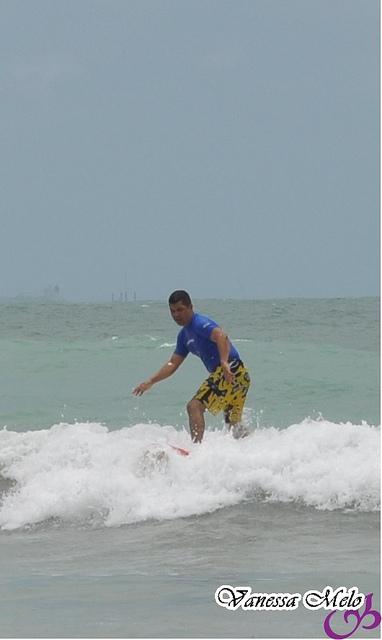What color are the man's shorts?
Short answer required. Yellow. Is everyone where a wetsuit?
Answer briefly. No. Is the surfer competing?
Be succinct. No. What causes the white in the water?
Give a very brief answer. Waves. Are waves formed?
Be succinct. Yes. Is the person surfing?
Keep it brief. Yes. What color is the water?
Short answer required. Gray. What makes waves?
Give a very brief answer. Wind. 